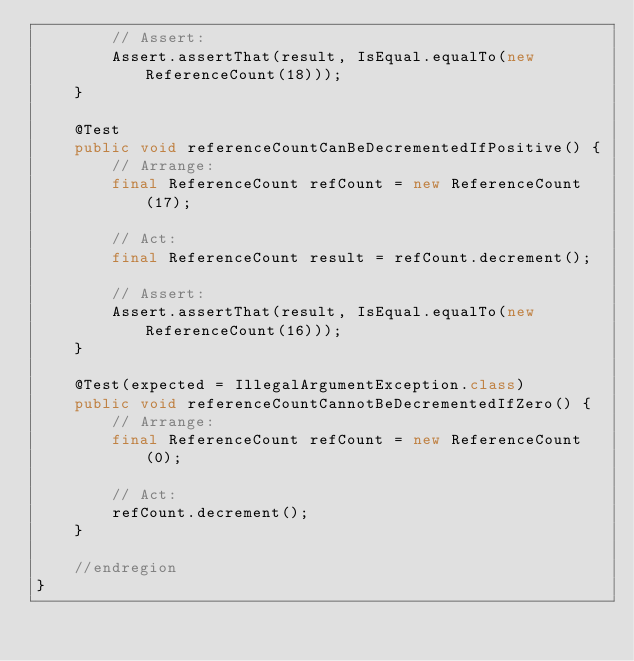<code> <loc_0><loc_0><loc_500><loc_500><_Java_>		// Assert:
		Assert.assertThat(result, IsEqual.equalTo(new ReferenceCount(18)));
	}

	@Test
	public void referenceCountCanBeDecrementedIfPositive() {
		// Arrange:
		final ReferenceCount refCount = new ReferenceCount(17);

		// Act:
		final ReferenceCount result = refCount.decrement();

		// Assert:
		Assert.assertThat(result, IsEqual.equalTo(new ReferenceCount(16)));
	}

	@Test(expected = IllegalArgumentException.class)
	public void referenceCountCannotBeDecrementedIfZero() {
		// Arrange:
		final ReferenceCount refCount = new ReferenceCount(0);

		// Act:
		refCount.decrement();
	}

	//endregion
}
</code> 